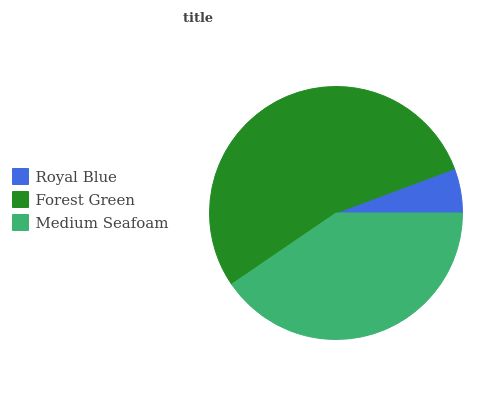Is Royal Blue the minimum?
Answer yes or no. Yes. Is Forest Green the maximum?
Answer yes or no. Yes. Is Medium Seafoam the minimum?
Answer yes or no. No. Is Medium Seafoam the maximum?
Answer yes or no. No. Is Forest Green greater than Medium Seafoam?
Answer yes or no. Yes. Is Medium Seafoam less than Forest Green?
Answer yes or no. Yes. Is Medium Seafoam greater than Forest Green?
Answer yes or no. No. Is Forest Green less than Medium Seafoam?
Answer yes or no. No. Is Medium Seafoam the high median?
Answer yes or no. Yes. Is Medium Seafoam the low median?
Answer yes or no. Yes. Is Royal Blue the high median?
Answer yes or no. No. Is Forest Green the low median?
Answer yes or no. No. 